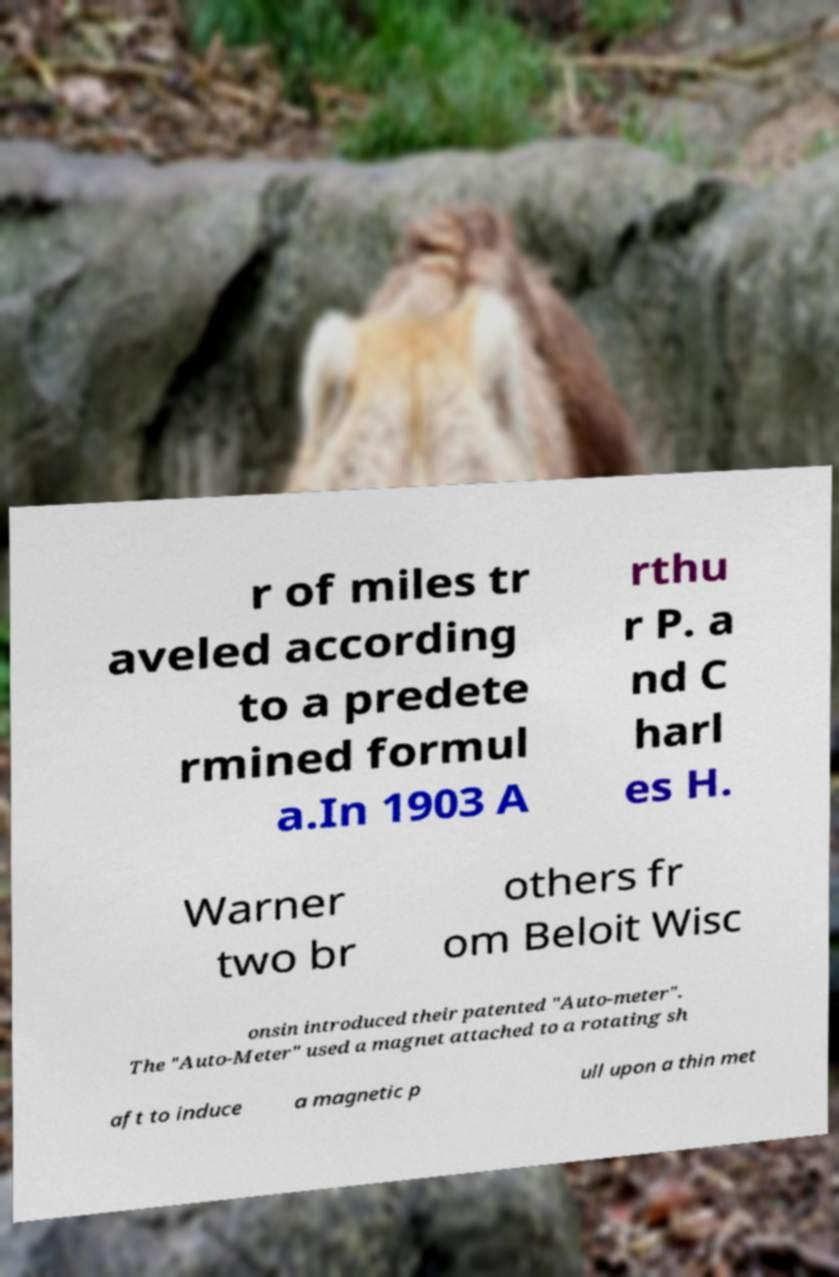There's text embedded in this image that I need extracted. Can you transcribe it verbatim? r of miles tr aveled according to a predete rmined formul a.In 1903 A rthu r P. a nd C harl es H. Warner two br others fr om Beloit Wisc onsin introduced their patented "Auto-meter". The "Auto-Meter" used a magnet attached to a rotating sh aft to induce a magnetic p ull upon a thin met 